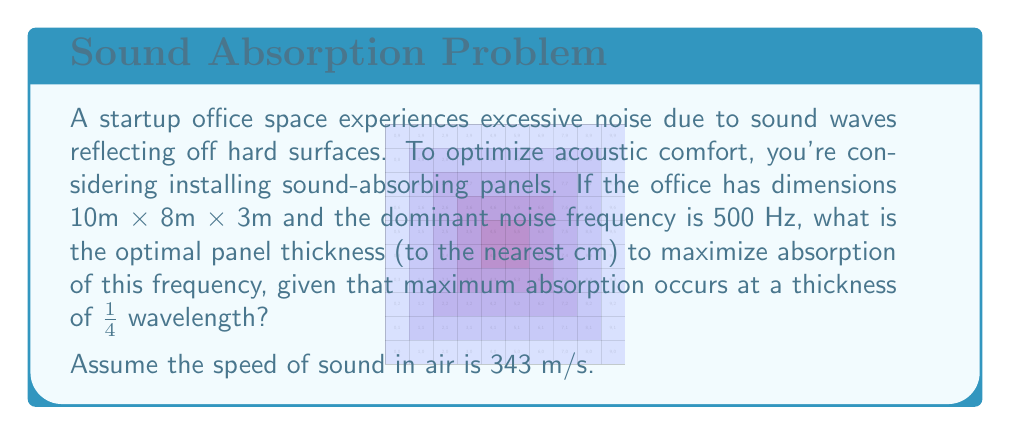Help me with this question. To solve this problem, we'll follow these steps:

1) First, we need to calculate the wavelength of the dominant noise frequency.
   The wave equation is: $$v = f\lambda$$
   where $v$ is the speed of sound, $f$ is the frequency, and $\lambda$ is the wavelength.

2) Rearranging the equation to solve for $\lambda$:
   $$\lambda = \frac{v}{f}$$

3) Substituting the values:
   $$\lambda = \frac{343 \text{ m/s}}{500 \text{ Hz}} = 0.686 \text{ m}$$

4) The question states that maximum absorption occurs at 1/4 wavelength. So, the optimal thickness is:
   $$\text{Optimal Thickness} = \frac{1}{4} \lambda = \frac{1}{4} \times 0.686 \text{ m} = 0.1715 \text{ m}$$

5) Converting to centimeters:
   $$0.1715 \text{ m} \times 100 \text{ cm/m} = 17.15 \text{ cm}$$

6) Rounding to the nearest cm as requested:
   $$17.15 \text{ cm} \approx 17 \text{ cm}$$

Therefore, the optimal panel thickness to maximize absorption of the 500 Hz frequency is 17 cm.
Answer: 17 cm 